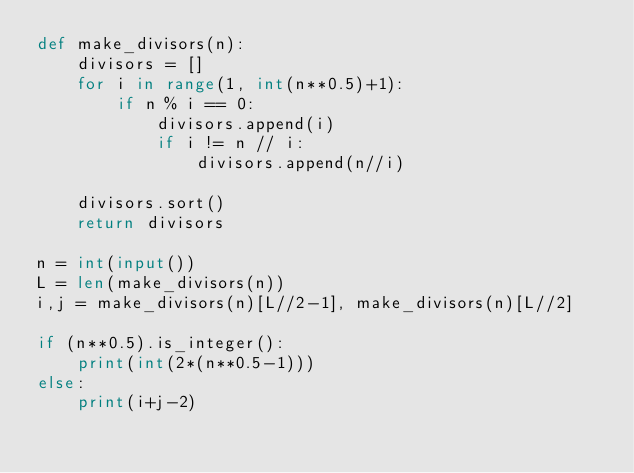<code> <loc_0><loc_0><loc_500><loc_500><_Python_>def make_divisors(n):
    divisors = []
    for i in range(1, int(n**0.5)+1):
        if n % i == 0:
            divisors.append(i)
            if i != n // i:
                divisors.append(n//i)

    divisors.sort()
    return divisors

n = int(input())
L = len(make_divisors(n))
i,j = make_divisors(n)[L//2-1], make_divisors(n)[L//2]

if (n**0.5).is_integer():
    print(int(2*(n**0.5-1)))
else:
    print(i+j-2)
</code> 